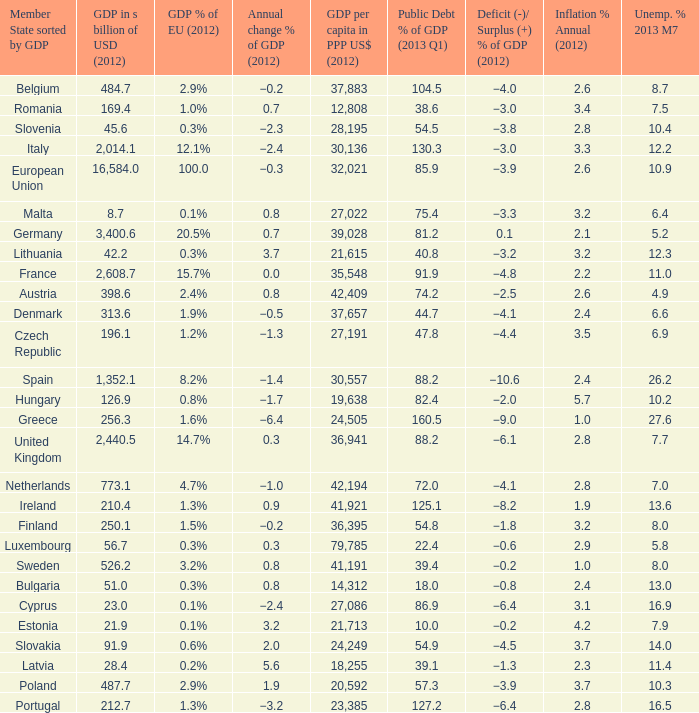What is the largest inflation % annual in 2012 of the country with a public debt % of GDP in 2013 Q1 greater than 88.2 and a GDP % of EU in 2012 of 2.9%? 2.6. 